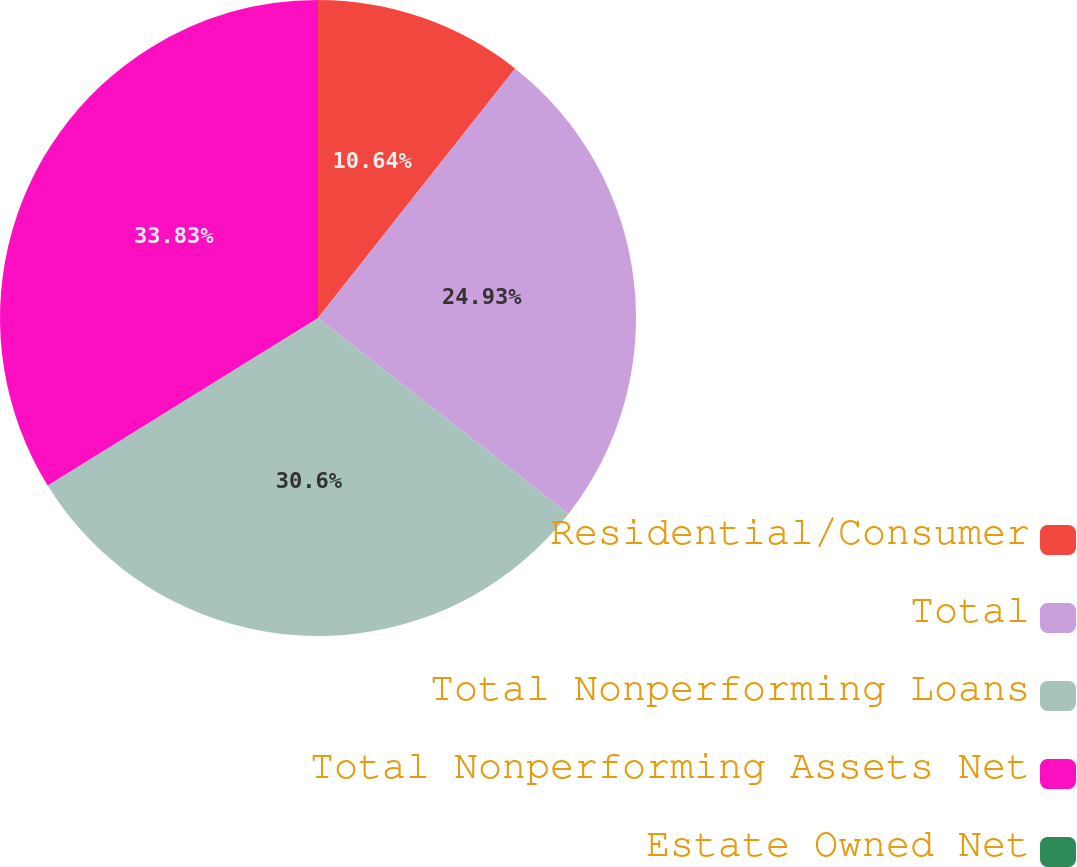Convert chart. <chart><loc_0><loc_0><loc_500><loc_500><pie_chart><fcel>Residential/Consumer<fcel>Total<fcel>Total Nonperforming Loans<fcel>Total Nonperforming Assets Net<fcel>Estate Owned Net<nl><fcel>10.64%<fcel>24.93%<fcel>30.6%<fcel>33.83%<fcel>0.0%<nl></chart> 